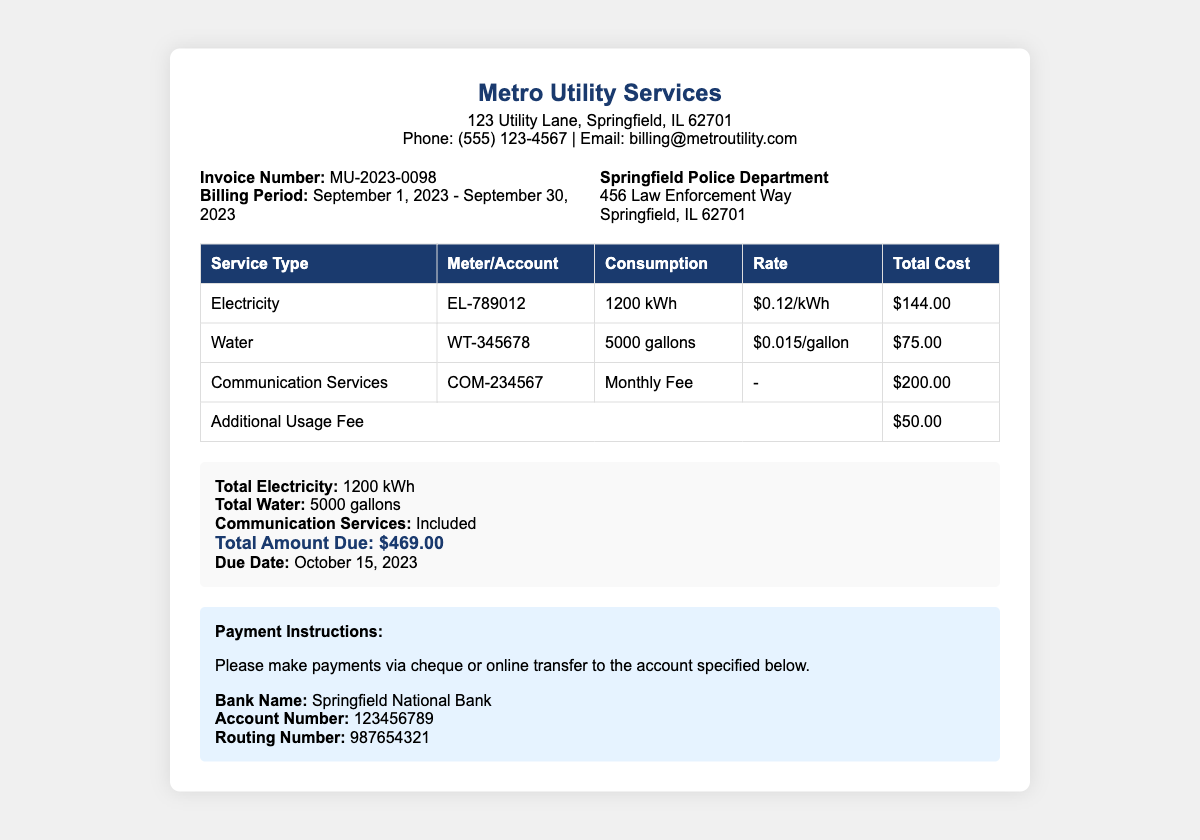What is the invoice number? The invoice number is specified directly in the document under the bill information section.
Answer: MU-2023-0098 What is the billing period? The billing period is detailed in the document and includes the start and end dates for the services billed.
Answer: September 1, 2023 - September 30, 2023 How much was charged for electricity consumption? The total cost for electricity is provided in the table and reflects the specific usage amount.
Answer: $144.00 What was the total water consumption? The document includes a breakdown of the water consumption in gallons within the table.
Answer: 5000 gallons What is the total amount due? The total due is summarized at the end of the bill and reflects all charges combined.
Answer: $469.00 What is the due date for payment? The due date for payment is distinctly mentioned towards the conclusion of the document.
Answer: October 15, 2023 What is the rate for water? The rate for water is directly mentioned in the consumption table associated with the water service.
Answer: $0.015/gallon What additional fee is listed in the bill? The bill specifies an additional fee for usage that is distinct from the listed utilities.
Answer: $50.00 What is the account number for the bank? The account number is provided in the payment instructions section for making payments.
Answer: 123456789 